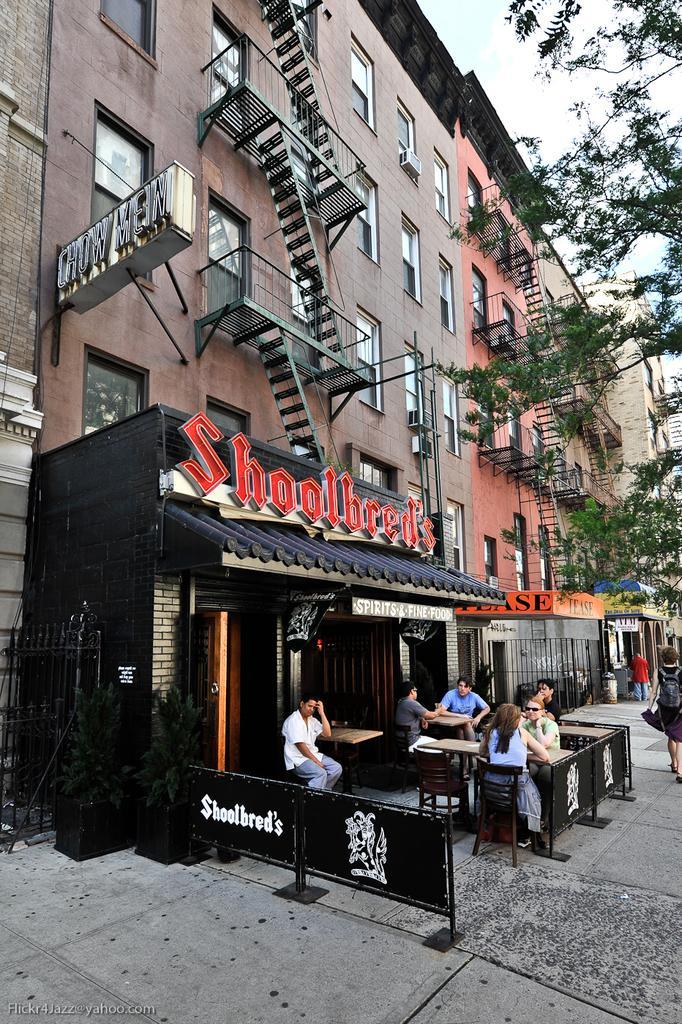Can you describe this image briefly? The picture is taken on the street on which there is a store and there are people sitting in the chairs in front of that store. At the back side there is a building which has stair case,window and a hoarding to it. To the right side there is a big tree. 